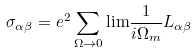Convert formula to latex. <formula><loc_0><loc_0><loc_500><loc_500>\sigma _ { \alpha \beta } = e ^ { 2 } \sum _ { \Omega \rightarrow 0 } { \lim } \frac { 1 } { i \Omega _ { m } } L _ { \alpha \beta }</formula> 